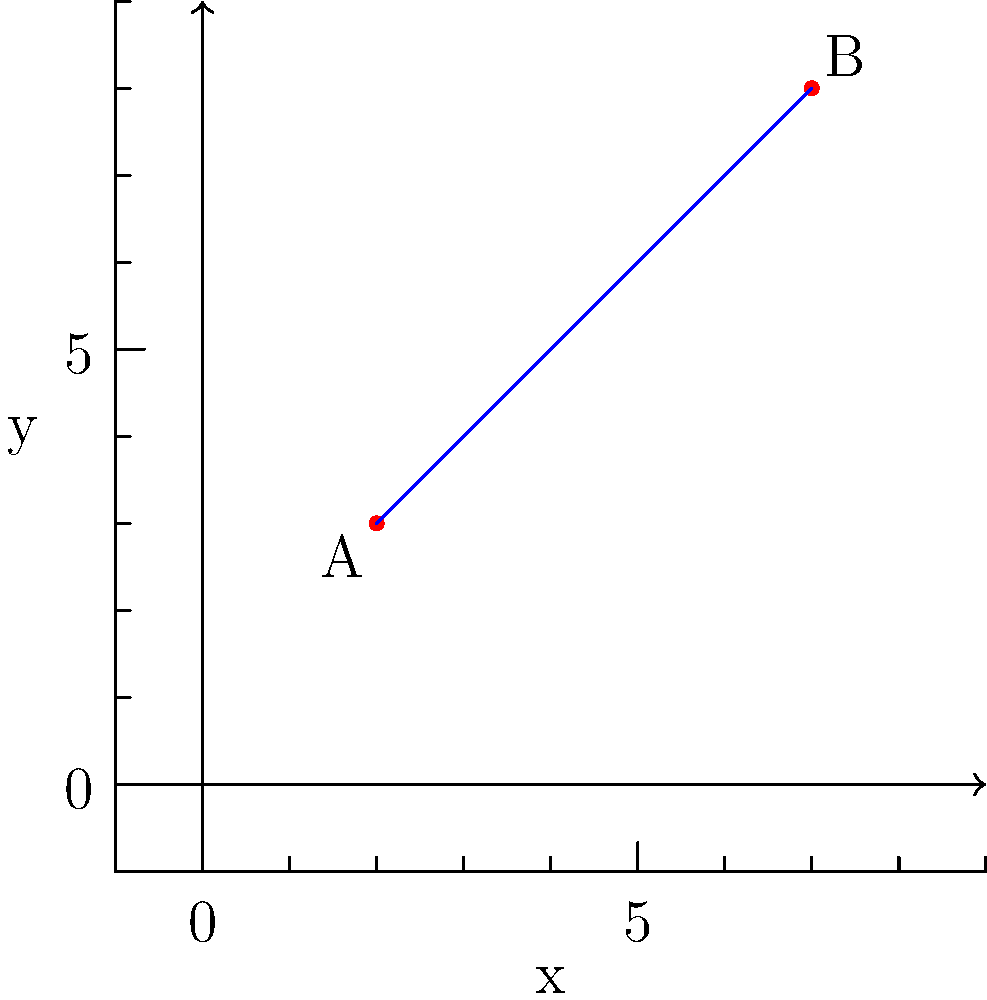As a diligent employee, you've been tasked with calculating the slope of a line passing through two points on a graph. Your supervisor has provided you with the coordinates of points A(2,3) and B(7,8). Calculate the slope of the line AB to demonstrate your understanding and attention to detail. Round your answer to two decimal places. To calculate the slope of a line passing through two points, we use the slope formula:

$$ m = \frac{y_2 - y_1}{x_2 - x_1} $$

Where $(x_1, y_1)$ are the coordinates of the first point and $(x_2, y_2)$ are the coordinates of the second point.

Given:
Point A: $(x_1, y_1) = (2, 3)$
Point B: $(x_2, y_2) = (7, 8)$

Let's substitute these values into the formula:

$$ m = \frac{8 - 3}{7 - 2} = \frac{5}{5} = 1 $$

The slope of the line AB is exactly 1.

To demonstrate attention to detail, we'll round to two decimal places as requested:

$$ m \approx 1.00 $$

This result shows that for every 1 unit increase in x, y also increases by 1 unit, indicating a 45-degree angle with the x-axis.
Answer: 1.00 